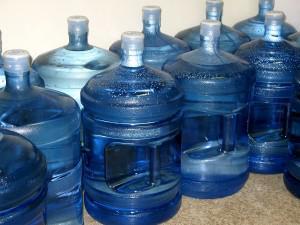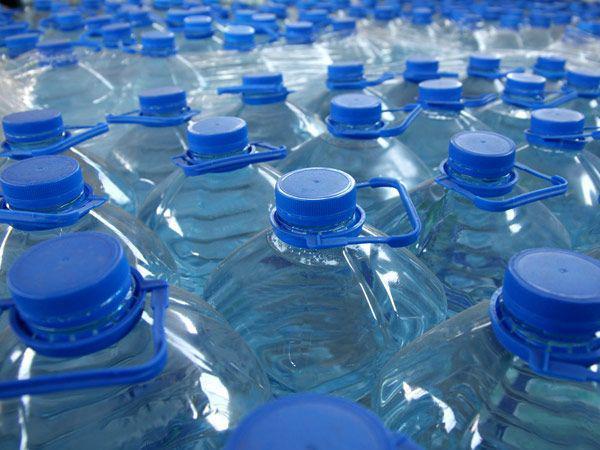The first image is the image on the left, the second image is the image on the right. Considering the images on both sides, is "An image shows at least one water bottle with a loop handle on the lid." valid? Answer yes or no. Yes. 